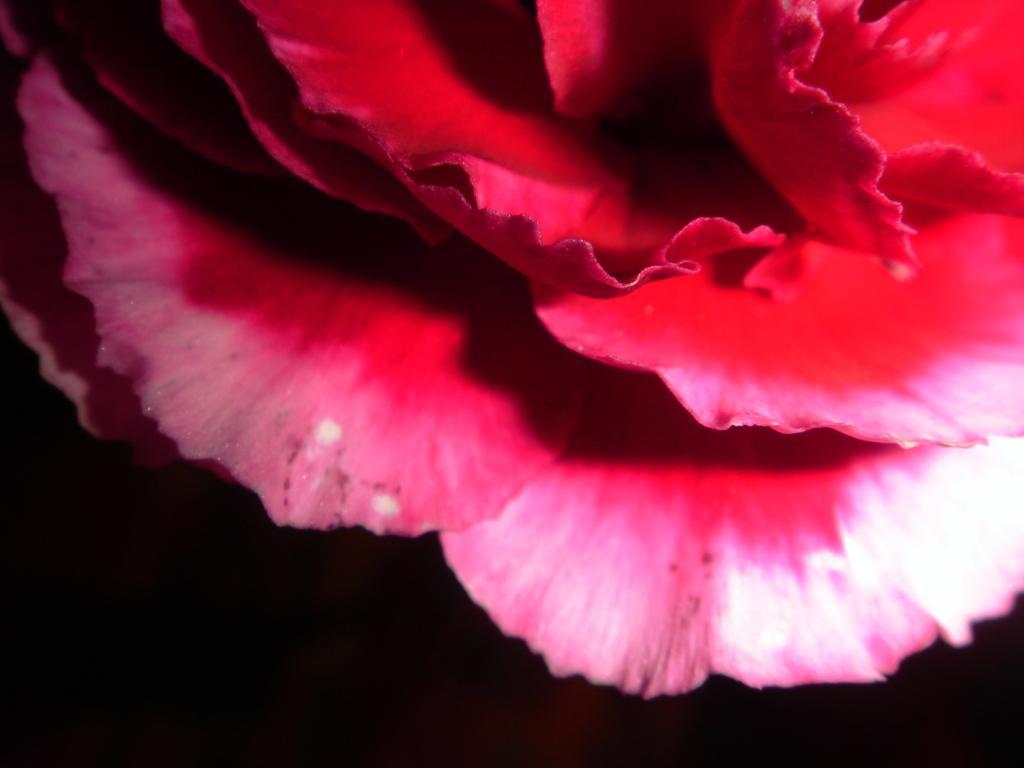Describe this image in one or two sentences. In this picture I can see a flower and a dark background. 